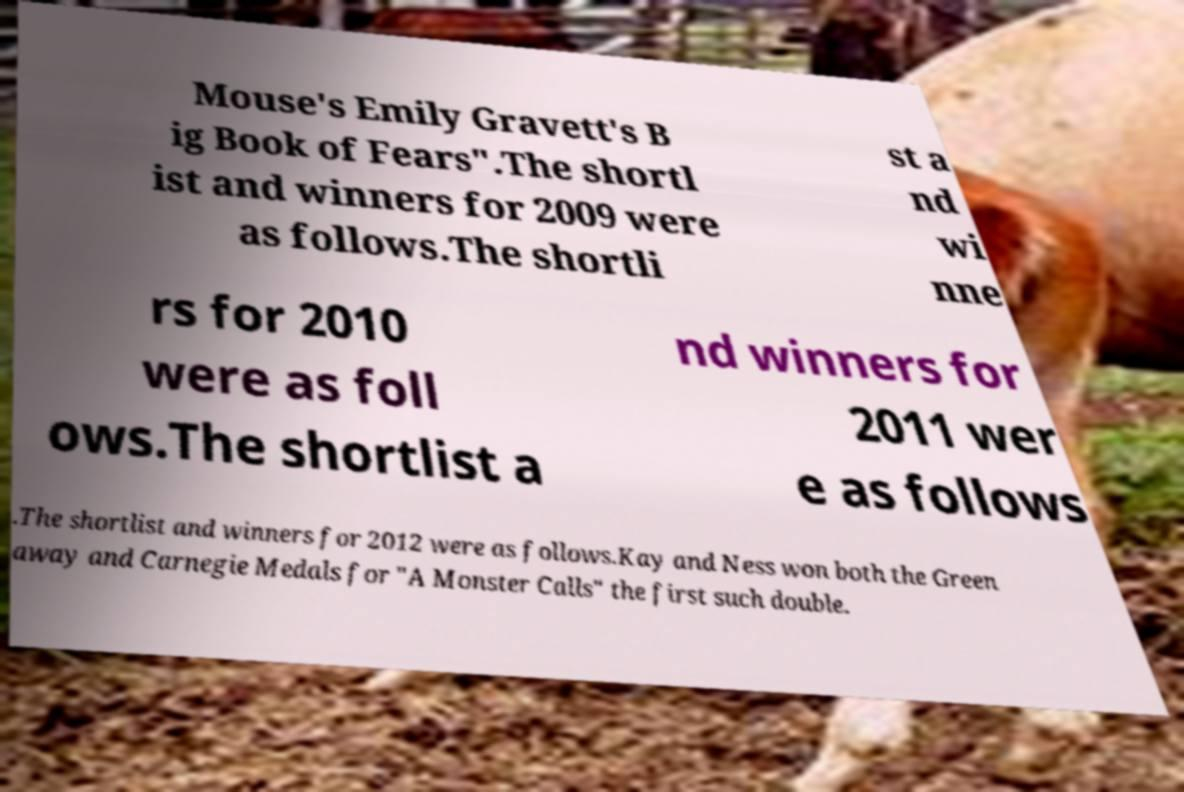What messages or text are displayed in this image? I need them in a readable, typed format. Mouse's Emily Gravett's B ig Book of Fears".The shortl ist and winners for 2009 were as follows.The shortli st a nd wi nne rs for 2010 were as foll ows.The shortlist a nd winners for 2011 wer e as follows .The shortlist and winners for 2012 were as follows.Kay and Ness won both the Green away and Carnegie Medals for "A Monster Calls" the first such double. 